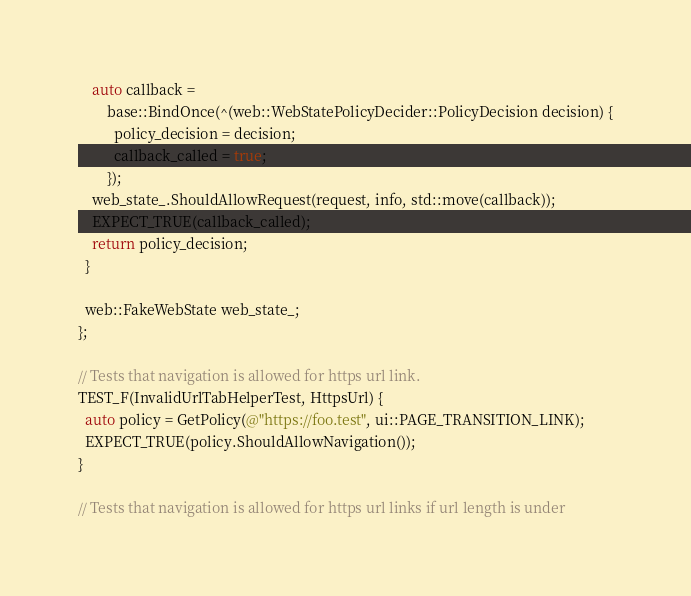Convert code to text. <code><loc_0><loc_0><loc_500><loc_500><_ObjectiveC_>    auto callback =
        base::BindOnce(^(web::WebStatePolicyDecider::PolicyDecision decision) {
          policy_decision = decision;
          callback_called = true;
        });
    web_state_.ShouldAllowRequest(request, info, std::move(callback));
    EXPECT_TRUE(callback_called);
    return policy_decision;
  }

  web::FakeWebState web_state_;
};

// Tests that navigation is allowed for https url link.
TEST_F(InvalidUrlTabHelperTest, HttpsUrl) {
  auto policy = GetPolicy(@"https://foo.test", ui::PAGE_TRANSITION_LINK);
  EXPECT_TRUE(policy.ShouldAllowNavigation());
}

// Tests that navigation is allowed for https url links if url length is under</code> 